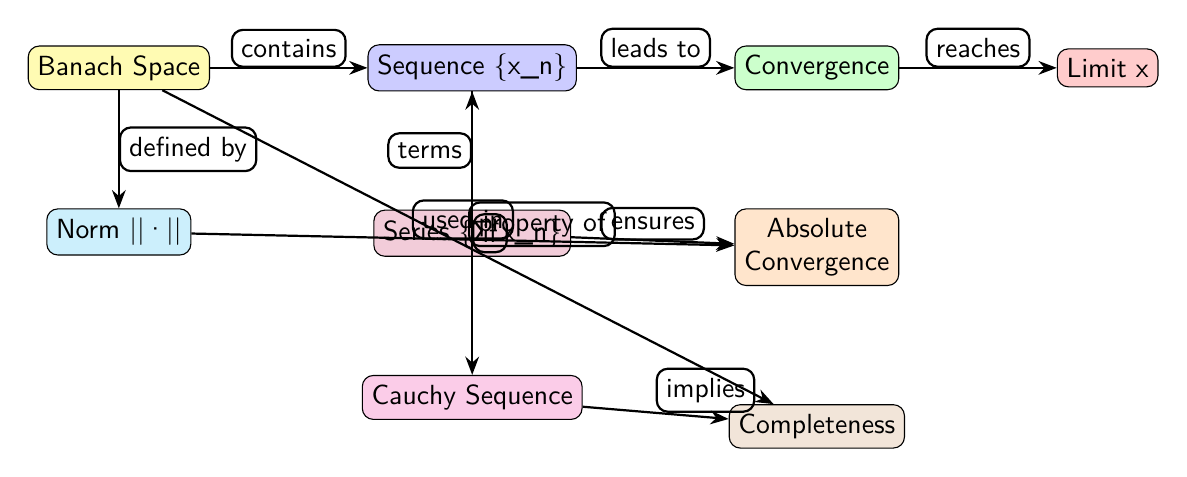What is the first node in the diagram? The first node in the diagram is labeled "Banach Space." This node is positioned at the top left, signifying it as the foundational element of the diagram.
Answer: Banach Space How many nodes are present in the diagram? The diagram consists of nine distinct nodes, each representing different concepts related to the convergence of sequences and series in Banach spaces.
Answer: 9 Which node is linked to "Cauchy Sequence"? The node "Cauchy Sequence" is connected from the node labeled "Sequence {x_n}," indicating a relationship where a sequence can be classified as Cauchy based on certain properties.
Answer: Sequence {x_n} What does "Absolute Convergence" ensure? "Absolute Convergence" ensures the connection to the "Series {Σ x_n}" node in the diagram, indicating that achieving absolute convergence is a condition related to the series composed of the sequence.
Answer: Series {Σ x_n} Explain the connection from "Series {Σ x_n}" to "Absolute Convergence." The connection from "Series {Σ x_n}" to "Absolute Convergence" indicates that the series of the sequence contributes to the determination of whether the series converges absolutely, which is a fundamental aspect of series evaluation.
Answer: ensures Which node leads to "Limit x"? The node that leads to "Limit x" is "Convergence." This relationship indicates that for a sequence to reach its limit, it must converge according to the properties defined in the Banach space.
Answer: Convergence How does a "Cauchy Sequence" relate to "Completeness"? A "Cauchy Sequence" implies "Completeness" as it indicates that if every Cauchy sequence within the space converges, the space is considered complete, establishing an important foundational property in functional analysis.
Answer: implies 